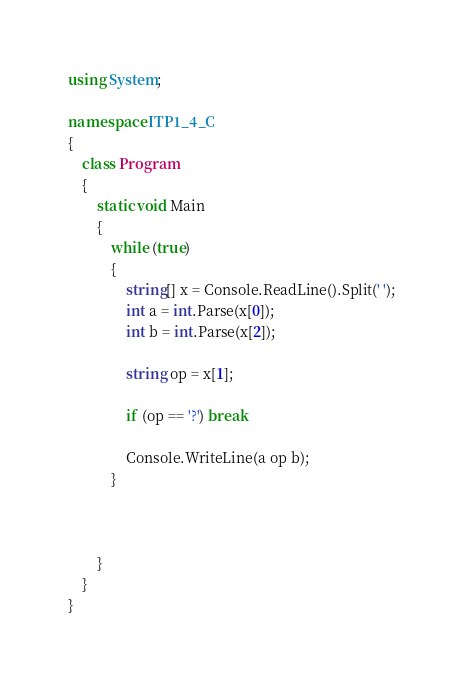<code> <loc_0><loc_0><loc_500><loc_500><_C#_>using System;

namespace ITP1_4_C
{
    class Program
    {
        static void Main
        {
            while (true)
            {
                string[] x = Console.ReadLine().Split(' ');
                int a = int.Parse(x[0]);
                int b = int.Parse(x[2]);
            
                string op = x[1];
                
                if (op == '?') break
                
                Console.WriteLine(a op b);
            }
            
            
            
        }
    }
}
</code> 